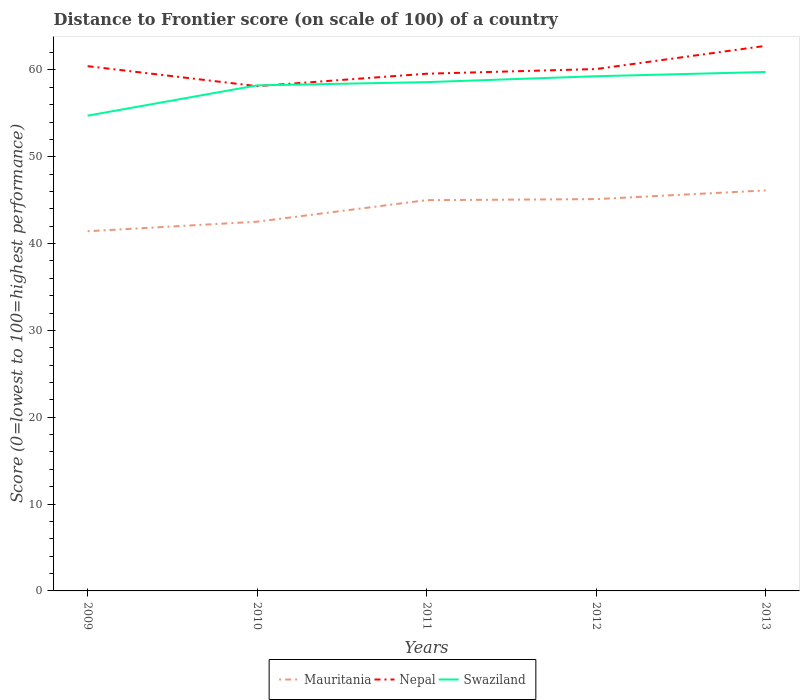How many different coloured lines are there?
Your answer should be very brief. 3. Does the line corresponding to Mauritania intersect with the line corresponding to Nepal?
Your answer should be very brief. No. Across all years, what is the maximum distance to frontier score of in Nepal?
Provide a succinct answer. 58.13. In which year was the distance to frontier score of in Swaziland maximum?
Provide a succinct answer. 2009. What is the total distance to frontier score of in Nepal in the graph?
Keep it short and to the point. -0.54. What is the difference between the highest and the second highest distance to frontier score of in Nepal?
Your answer should be very brief. 4.64. Does the graph contain any zero values?
Your answer should be compact. No. Does the graph contain grids?
Offer a very short reply. No. Where does the legend appear in the graph?
Your answer should be compact. Bottom center. How are the legend labels stacked?
Give a very brief answer. Horizontal. What is the title of the graph?
Provide a succinct answer. Distance to Frontier score (on scale of 100) of a country. Does "Other small states" appear as one of the legend labels in the graph?
Your answer should be very brief. No. What is the label or title of the Y-axis?
Ensure brevity in your answer.  Score (0=lowest to 100=highest performance). What is the Score (0=lowest to 100=highest performance) of Mauritania in 2009?
Provide a succinct answer. 41.42. What is the Score (0=lowest to 100=highest performance) in Nepal in 2009?
Make the answer very short. 60.43. What is the Score (0=lowest to 100=highest performance) of Swaziland in 2009?
Your answer should be compact. 54.73. What is the Score (0=lowest to 100=highest performance) in Mauritania in 2010?
Make the answer very short. 42.52. What is the Score (0=lowest to 100=highest performance) in Nepal in 2010?
Make the answer very short. 58.13. What is the Score (0=lowest to 100=highest performance) of Swaziland in 2010?
Your answer should be compact. 58.22. What is the Score (0=lowest to 100=highest performance) of Mauritania in 2011?
Your answer should be compact. 45. What is the Score (0=lowest to 100=highest performance) in Nepal in 2011?
Offer a terse response. 59.56. What is the Score (0=lowest to 100=highest performance) in Swaziland in 2011?
Your answer should be very brief. 58.59. What is the Score (0=lowest to 100=highest performance) of Mauritania in 2012?
Your response must be concise. 45.12. What is the Score (0=lowest to 100=highest performance) of Nepal in 2012?
Provide a short and direct response. 60.1. What is the Score (0=lowest to 100=highest performance) of Swaziland in 2012?
Your answer should be very brief. 59.27. What is the Score (0=lowest to 100=highest performance) of Mauritania in 2013?
Give a very brief answer. 46.12. What is the Score (0=lowest to 100=highest performance) in Nepal in 2013?
Provide a succinct answer. 62.77. What is the Score (0=lowest to 100=highest performance) of Swaziland in 2013?
Provide a succinct answer. 59.76. Across all years, what is the maximum Score (0=lowest to 100=highest performance) in Mauritania?
Provide a short and direct response. 46.12. Across all years, what is the maximum Score (0=lowest to 100=highest performance) of Nepal?
Make the answer very short. 62.77. Across all years, what is the maximum Score (0=lowest to 100=highest performance) of Swaziland?
Ensure brevity in your answer.  59.76. Across all years, what is the minimum Score (0=lowest to 100=highest performance) in Mauritania?
Offer a terse response. 41.42. Across all years, what is the minimum Score (0=lowest to 100=highest performance) in Nepal?
Your answer should be very brief. 58.13. Across all years, what is the minimum Score (0=lowest to 100=highest performance) of Swaziland?
Offer a very short reply. 54.73. What is the total Score (0=lowest to 100=highest performance) in Mauritania in the graph?
Your response must be concise. 220.18. What is the total Score (0=lowest to 100=highest performance) of Nepal in the graph?
Your response must be concise. 300.99. What is the total Score (0=lowest to 100=highest performance) in Swaziland in the graph?
Provide a short and direct response. 290.57. What is the difference between the Score (0=lowest to 100=highest performance) of Mauritania in 2009 and that in 2010?
Keep it short and to the point. -1.1. What is the difference between the Score (0=lowest to 100=highest performance) in Swaziland in 2009 and that in 2010?
Ensure brevity in your answer.  -3.49. What is the difference between the Score (0=lowest to 100=highest performance) of Mauritania in 2009 and that in 2011?
Offer a very short reply. -3.58. What is the difference between the Score (0=lowest to 100=highest performance) in Nepal in 2009 and that in 2011?
Provide a short and direct response. 0.87. What is the difference between the Score (0=lowest to 100=highest performance) of Swaziland in 2009 and that in 2011?
Provide a succinct answer. -3.86. What is the difference between the Score (0=lowest to 100=highest performance) of Mauritania in 2009 and that in 2012?
Keep it short and to the point. -3.7. What is the difference between the Score (0=lowest to 100=highest performance) of Nepal in 2009 and that in 2012?
Your answer should be very brief. 0.33. What is the difference between the Score (0=lowest to 100=highest performance) in Swaziland in 2009 and that in 2012?
Your response must be concise. -4.54. What is the difference between the Score (0=lowest to 100=highest performance) in Mauritania in 2009 and that in 2013?
Make the answer very short. -4.7. What is the difference between the Score (0=lowest to 100=highest performance) in Nepal in 2009 and that in 2013?
Give a very brief answer. -2.34. What is the difference between the Score (0=lowest to 100=highest performance) in Swaziland in 2009 and that in 2013?
Your response must be concise. -5.03. What is the difference between the Score (0=lowest to 100=highest performance) of Mauritania in 2010 and that in 2011?
Your response must be concise. -2.48. What is the difference between the Score (0=lowest to 100=highest performance) in Nepal in 2010 and that in 2011?
Ensure brevity in your answer.  -1.43. What is the difference between the Score (0=lowest to 100=highest performance) in Swaziland in 2010 and that in 2011?
Your answer should be compact. -0.37. What is the difference between the Score (0=lowest to 100=highest performance) in Mauritania in 2010 and that in 2012?
Provide a short and direct response. -2.6. What is the difference between the Score (0=lowest to 100=highest performance) of Nepal in 2010 and that in 2012?
Your answer should be compact. -1.97. What is the difference between the Score (0=lowest to 100=highest performance) of Swaziland in 2010 and that in 2012?
Your answer should be compact. -1.05. What is the difference between the Score (0=lowest to 100=highest performance) of Nepal in 2010 and that in 2013?
Give a very brief answer. -4.64. What is the difference between the Score (0=lowest to 100=highest performance) in Swaziland in 2010 and that in 2013?
Give a very brief answer. -1.54. What is the difference between the Score (0=lowest to 100=highest performance) of Mauritania in 2011 and that in 2012?
Make the answer very short. -0.12. What is the difference between the Score (0=lowest to 100=highest performance) in Nepal in 2011 and that in 2012?
Your response must be concise. -0.54. What is the difference between the Score (0=lowest to 100=highest performance) in Swaziland in 2011 and that in 2012?
Your answer should be compact. -0.68. What is the difference between the Score (0=lowest to 100=highest performance) of Mauritania in 2011 and that in 2013?
Your response must be concise. -1.12. What is the difference between the Score (0=lowest to 100=highest performance) of Nepal in 2011 and that in 2013?
Ensure brevity in your answer.  -3.21. What is the difference between the Score (0=lowest to 100=highest performance) of Swaziland in 2011 and that in 2013?
Ensure brevity in your answer.  -1.17. What is the difference between the Score (0=lowest to 100=highest performance) of Mauritania in 2012 and that in 2013?
Your response must be concise. -1. What is the difference between the Score (0=lowest to 100=highest performance) in Nepal in 2012 and that in 2013?
Make the answer very short. -2.67. What is the difference between the Score (0=lowest to 100=highest performance) in Swaziland in 2012 and that in 2013?
Your response must be concise. -0.49. What is the difference between the Score (0=lowest to 100=highest performance) in Mauritania in 2009 and the Score (0=lowest to 100=highest performance) in Nepal in 2010?
Keep it short and to the point. -16.71. What is the difference between the Score (0=lowest to 100=highest performance) in Mauritania in 2009 and the Score (0=lowest to 100=highest performance) in Swaziland in 2010?
Offer a terse response. -16.8. What is the difference between the Score (0=lowest to 100=highest performance) in Nepal in 2009 and the Score (0=lowest to 100=highest performance) in Swaziland in 2010?
Your answer should be very brief. 2.21. What is the difference between the Score (0=lowest to 100=highest performance) in Mauritania in 2009 and the Score (0=lowest to 100=highest performance) in Nepal in 2011?
Your answer should be very brief. -18.14. What is the difference between the Score (0=lowest to 100=highest performance) in Mauritania in 2009 and the Score (0=lowest to 100=highest performance) in Swaziland in 2011?
Offer a terse response. -17.17. What is the difference between the Score (0=lowest to 100=highest performance) in Nepal in 2009 and the Score (0=lowest to 100=highest performance) in Swaziland in 2011?
Provide a succinct answer. 1.84. What is the difference between the Score (0=lowest to 100=highest performance) of Mauritania in 2009 and the Score (0=lowest to 100=highest performance) of Nepal in 2012?
Ensure brevity in your answer.  -18.68. What is the difference between the Score (0=lowest to 100=highest performance) of Mauritania in 2009 and the Score (0=lowest to 100=highest performance) of Swaziland in 2012?
Give a very brief answer. -17.85. What is the difference between the Score (0=lowest to 100=highest performance) in Nepal in 2009 and the Score (0=lowest to 100=highest performance) in Swaziland in 2012?
Ensure brevity in your answer.  1.16. What is the difference between the Score (0=lowest to 100=highest performance) of Mauritania in 2009 and the Score (0=lowest to 100=highest performance) of Nepal in 2013?
Give a very brief answer. -21.35. What is the difference between the Score (0=lowest to 100=highest performance) of Mauritania in 2009 and the Score (0=lowest to 100=highest performance) of Swaziland in 2013?
Ensure brevity in your answer.  -18.34. What is the difference between the Score (0=lowest to 100=highest performance) of Nepal in 2009 and the Score (0=lowest to 100=highest performance) of Swaziland in 2013?
Provide a succinct answer. 0.67. What is the difference between the Score (0=lowest to 100=highest performance) of Mauritania in 2010 and the Score (0=lowest to 100=highest performance) of Nepal in 2011?
Your answer should be compact. -17.04. What is the difference between the Score (0=lowest to 100=highest performance) of Mauritania in 2010 and the Score (0=lowest to 100=highest performance) of Swaziland in 2011?
Offer a very short reply. -16.07. What is the difference between the Score (0=lowest to 100=highest performance) of Nepal in 2010 and the Score (0=lowest to 100=highest performance) of Swaziland in 2011?
Offer a terse response. -0.46. What is the difference between the Score (0=lowest to 100=highest performance) in Mauritania in 2010 and the Score (0=lowest to 100=highest performance) in Nepal in 2012?
Ensure brevity in your answer.  -17.58. What is the difference between the Score (0=lowest to 100=highest performance) of Mauritania in 2010 and the Score (0=lowest to 100=highest performance) of Swaziland in 2012?
Your answer should be compact. -16.75. What is the difference between the Score (0=lowest to 100=highest performance) of Nepal in 2010 and the Score (0=lowest to 100=highest performance) of Swaziland in 2012?
Your answer should be very brief. -1.14. What is the difference between the Score (0=lowest to 100=highest performance) of Mauritania in 2010 and the Score (0=lowest to 100=highest performance) of Nepal in 2013?
Your response must be concise. -20.25. What is the difference between the Score (0=lowest to 100=highest performance) in Mauritania in 2010 and the Score (0=lowest to 100=highest performance) in Swaziland in 2013?
Your answer should be very brief. -17.24. What is the difference between the Score (0=lowest to 100=highest performance) of Nepal in 2010 and the Score (0=lowest to 100=highest performance) of Swaziland in 2013?
Ensure brevity in your answer.  -1.63. What is the difference between the Score (0=lowest to 100=highest performance) of Mauritania in 2011 and the Score (0=lowest to 100=highest performance) of Nepal in 2012?
Keep it short and to the point. -15.1. What is the difference between the Score (0=lowest to 100=highest performance) in Mauritania in 2011 and the Score (0=lowest to 100=highest performance) in Swaziland in 2012?
Provide a succinct answer. -14.27. What is the difference between the Score (0=lowest to 100=highest performance) of Nepal in 2011 and the Score (0=lowest to 100=highest performance) of Swaziland in 2012?
Provide a short and direct response. 0.29. What is the difference between the Score (0=lowest to 100=highest performance) of Mauritania in 2011 and the Score (0=lowest to 100=highest performance) of Nepal in 2013?
Provide a short and direct response. -17.77. What is the difference between the Score (0=lowest to 100=highest performance) of Mauritania in 2011 and the Score (0=lowest to 100=highest performance) of Swaziland in 2013?
Offer a terse response. -14.76. What is the difference between the Score (0=lowest to 100=highest performance) of Mauritania in 2012 and the Score (0=lowest to 100=highest performance) of Nepal in 2013?
Make the answer very short. -17.65. What is the difference between the Score (0=lowest to 100=highest performance) of Mauritania in 2012 and the Score (0=lowest to 100=highest performance) of Swaziland in 2013?
Ensure brevity in your answer.  -14.64. What is the difference between the Score (0=lowest to 100=highest performance) in Nepal in 2012 and the Score (0=lowest to 100=highest performance) in Swaziland in 2013?
Your answer should be compact. 0.34. What is the average Score (0=lowest to 100=highest performance) of Mauritania per year?
Give a very brief answer. 44.04. What is the average Score (0=lowest to 100=highest performance) of Nepal per year?
Your answer should be very brief. 60.2. What is the average Score (0=lowest to 100=highest performance) in Swaziland per year?
Provide a succinct answer. 58.11. In the year 2009, what is the difference between the Score (0=lowest to 100=highest performance) of Mauritania and Score (0=lowest to 100=highest performance) of Nepal?
Your answer should be very brief. -19.01. In the year 2009, what is the difference between the Score (0=lowest to 100=highest performance) in Mauritania and Score (0=lowest to 100=highest performance) in Swaziland?
Your answer should be very brief. -13.31. In the year 2009, what is the difference between the Score (0=lowest to 100=highest performance) of Nepal and Score (0=lowest to 100=highest performance) of Swaziland?
Provide a succinct answer. 5.7. In the year 2010, what is the difference between the Score (0=lowest to 100=highest performance) of Mauritania and Score (0=lowest to 100=highest performance) of Nepal?
Your answer should be very brief. -15.61. In the year 2010, what is the difference between the Score (0=lowest to 100=highest performance) of Mauritania and Score (0=lowest to 100=highest performance) of Swaziland?
Make the answer very short. -15.7. In the year 2010, what is the difference between the Score (0=lowest to 100=highest performance) of Nepal and Score (0=lowest to 100=highest performance) of Swaziland?
Your response must be concise. -0.09. In the year 2011, what is the difference between the Score (0=lowest to 100=highest performance) of Mauritania and Score (0=lowest to 100=highest performance) of Nepal?
Offer a terse response. -14.56. In the year 2011, what is the difference between the Score (0=lowest to 100=highest performance) of Mauritania and Score (0=lowest to 100=highest performance) of Swaziland?
Offer a very short reply. -13.59. In the year 2012, what is the difference between the Score (0=lowest to 100=highest performance) in Mauritania and Score (0=lowest to 100=highest performance) in Nepal?
Your answer should be very brief. -14.98. In the year 2012, what is the difference between the Score (0=lowest to 100=highest performance) of Mauritania and Score (0=lowest to 100=highest performance) of Swaziland?
Keep it short and to the point. -14.15. In the year 2012, what is the difference between the Score (0=lowest to 100=highest performance) in Nepal and Score (0=lowest to 100=highest performance) in Swaziland?
Your response must be concise. 0.83. In the year 2013, what is the difference between the Score (0=lowest to 100=highest performance) in Mauritania and Score (0=lowest to 100=highest performance) in Nepal?
Keep it short and to the point. -16.65. In the year 2013, what is the difference between the Score (0=lowest to 100=highest performance) of Mauritania and Score (0=lowest to 100=highest performance) of Swaziland?
Provide a succinct answer. -13.64. In the year 2013, what is the difference between the Score (0=lowest to 100=highest performance) of Nepal and Score (0=lowest to 100=highest performance) of Swaziland?
Give a very brief answer. 3.01. What is the ratio of the Score (0=lowest to 100=highest performance) in Mauritania in 2009 to that in 2010?
Provide a succinct answer. 0.97. What is the ratio of the Score (0=lowest to 100=highest performance) in Nepal in 2009 to that in 2010?
Give a very brief answer. 1.04. What is the ratio of the Score (0=lowest to 100=highest performance) in Swaziland in 2009 to that in 2010?
Your answer should be compact. 0.94. What is the ratio of the Score (0=lowest to 100=highest performance) of Mauritania in 2009 to that in 2011?
Make the answer very short. 0.92. What is the ratio of the Score (0=lowest to 100=highest performance) in Nepal in 2009 to that in 2011?
Your response must be concise. 1.01. What is the ratio of the Score (0=lowest to 100=highest performance) in Swaziland in 2009 to that in 2011?
Provide a short and direct response. 0.93. What is the ratio of the Score (0=lowest to 100=highest performance) in Mauritania in 2009 to that in 2012?
Ensure brevity in your answer.  0.92. What is the ratio of the Score (0=lowest to 100=highest performance) in Nepal in 2009 to that in 2012?
Your answer should be very brief. 1.01. What is the ratio of the Score (0=lowest to 100=highest performance) in Swaziland in 2009 to that in 2012?
Provide a short and direct response. 0.92. What is the ratio of the Score (0=lowest to 100=highest performance) in Mauritania in 2009 to that in 2013?
Provide a succinct answer. 0.9. What is the ratio of the Score (0=lowest to 100=highest performance) in Nepal in 2009 to that in 2013?
Your answer should be compact. 0.96. What is the ratio of the Score (0=lowest to 100=highest performance) of Swaziland in 2009 to that in 2013?
Your answer should be very brief. 0.92. What is the ratio of the Score (0=lowest to 100=highest performance) of Mauritania in 2010 to that in 2011?
Give a very brief answer. 0.94. What is the ratio of the Score (0=lowest to 100=highest performance) in Nepal in 2010 to that in 2011?
Offer a very short reply. 0.98. What is the ratio of the Score (0=lowest to 100=highest performance) in Swaziland in 2010 to that in 2011?
Your answer should be compact. 0.99. What is the ratio of the Score (0=lowest to 100=highest performance) in Mauritania in 2010 to that in 2012?
Your answer should be compact. 0.94. What is the ratio of the Score (0=lowest to 100=highest performance) of Nepal in 2010 to that in 2012?
Keep it short and to the point. 0.97. What is the ratio of the Score (0=lowest to 100=highest performance) of Swaziland in 2010 to that in 2012?
Ensure brevity in your answer.  0.98. What is the ratio of the Score (0=lowest to 100=highest performance) of Mauritania in 2010 to that in 2013?
Make the answer very short. 0.92. What is the ratio of the Score (0=lowest to 100=highest performance) of Nepal in 2010 to that in 2013?
Provide a succinct answer. 0.93. What is the ratio of the Score (0=lowest to 100=highest performance) in Swaziland in 2010 to that in 2013?
Provide a succinct answer. 0.97. What is the ratio of the Score (0=lowest to 100=highest performance) of Nepal in 2011 to that in 2012?
Keep it short and to the point. 0.99. What is the ratio of the Score (0=lowest to 100=highest performance) of Mauritania in 2011 to that in 2013?
Provide a succinct answer. 0.98. What is the ratio of the Score (0=lowest to 100=highest performance) of Nepal in 2011 to that in 2013?
Give a very brief answer. 0.95. What is the ratio of the Score (0=lowest to 100=highest performance) of Swaziland in 2011 to that in 2013?
Offer a terse response. 0.98. What is the ratio of the Score (0=lowest to 100=highest performance) in Mauritania in 2012 to that in 2013?
Keep it short and to the point. 0.98. What is the ratio of the Score (0=lowest to 100=highest performance) of Nepal in 2012 to that in 2013?
Ensure brevity in your answer.  0.96. What is the difference between the highest and the second highest Score (0=lowest to 100=highest performance) in Mauritania?
Make the answer very short. 1. What is the difference between the highest and the second highest Score (0=lowest to 100=highest performance) of Nepal?
Offer a very short reply. 2.34. What is the difference between the highest and the second highest Score (0=lowest to 100=highest performance) of Swaziland?
Keep it short and to the point. 0.49. What is the difference between the highest and the lowest Score (0=lowest to 100=highest performance) of Mauritania?
Offer a very short reply. 4.7. What is the difference between the highest and the lowest Score (0=lowest to 100=highest performance) of Nepal?
Offer a terse response. 4.64. What is the difference between the highest and the lowest Score (0=lowest to 100=highest performance) in Swaziland?
Offer a very short reply. 5.03. 